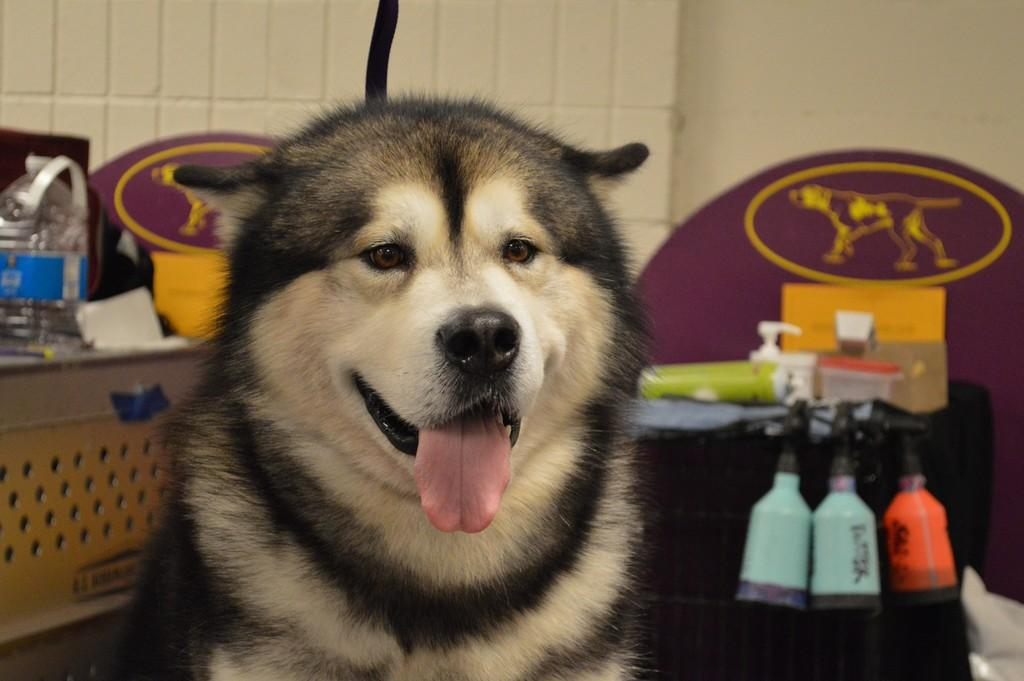What type of animal is present in the image? There is a dog in the image. Can you describe any objects in the background of the image? There is a bottle in the background of the image. What type of notebook is the dog using in the image? There is no notebook present in the image; it features a dog and a bottle in the background. 